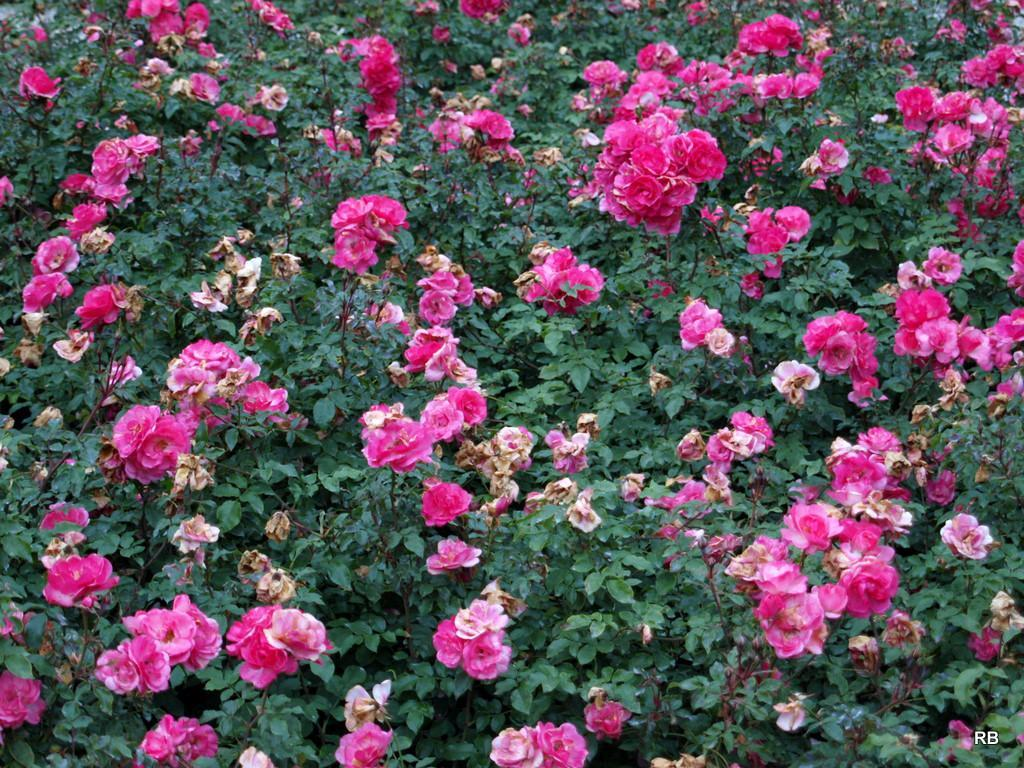What celestial bodies are shown in the image? There are planets depicted in the image. What type of flora is present in the image? There are many flowers in the image. Is there any additional information or branding on the image? Yes, there is a watermark on the image. Can you see a flame burning on any of the planets in the image? There is no flame present on any of the planets in the image. What type of trail can be seen coming from the flowers in the image? There is no trail coming from the flowers in the image. 